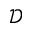Convert formula to latex. <formula><loc_0><loc_0><loc_500><loc_500>\mathcal { D }</formula> 